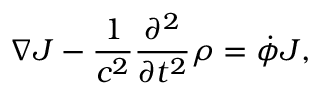Convert formula to latex. <formula><loc_0><loc_0><loc_500><loc_500>\nabla J - \frac { 1 } { c ^ { 2 } } \frac { \partial ^ { 2 } } { \partial t ^ { 2 } } \rho = \dot { \phi } J ,</formula> 